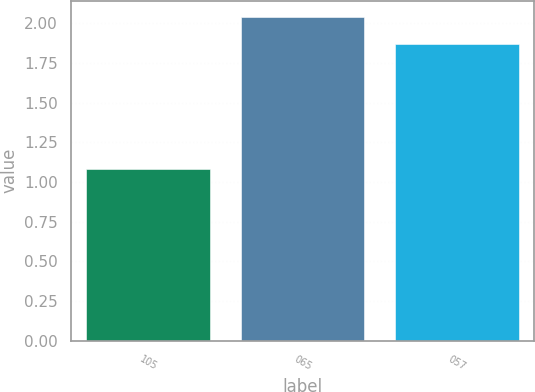Convert chart to OTSL. <chart><loc_0><loc_0><loc_500><loc_500><bar_chart><fcel>105<fcel>065<fcel>057<nl><fcel>1.08<fcel>2.04<fcel>1.87<nl></chart> 